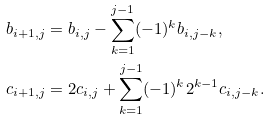Convert formula to latex. <formula><loc_0><loc_0><loc_500><loc_500>b _ { i + 1 , j } & = b _ { i , j } - \sum _ { k = 1 } ^ { j - 1 } ( - 1 ) ^ { k } b _ { i , j - k } , \\ c _ { i + 1 , j } & = 2 c _ { i , j } + \sum _ { k = 1 } ^ { j - 1 } ( - 1 ) ^ { k } 2 ^ { k - 1 } c _ { i , j - k } .</formula> 